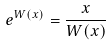Convert formula to latex. <formula><loc_0><loc_0><loc_500><loc_500>e ^ { W ( x ) } = \frac { x } { W ( x ) }</formula> 